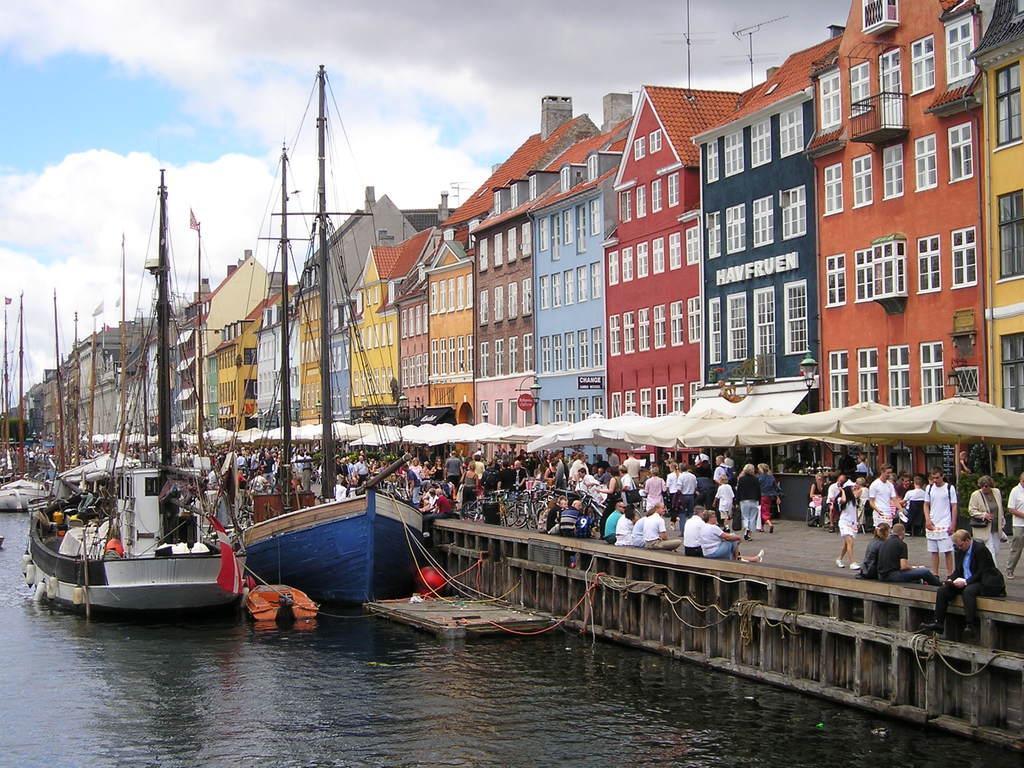Can you describe this image briefly? This image consists of buildings. There is sky in the top. There are boats in the left side. There are so many people in the middle. There are tents. There is water in the bottom. There are current polls. 